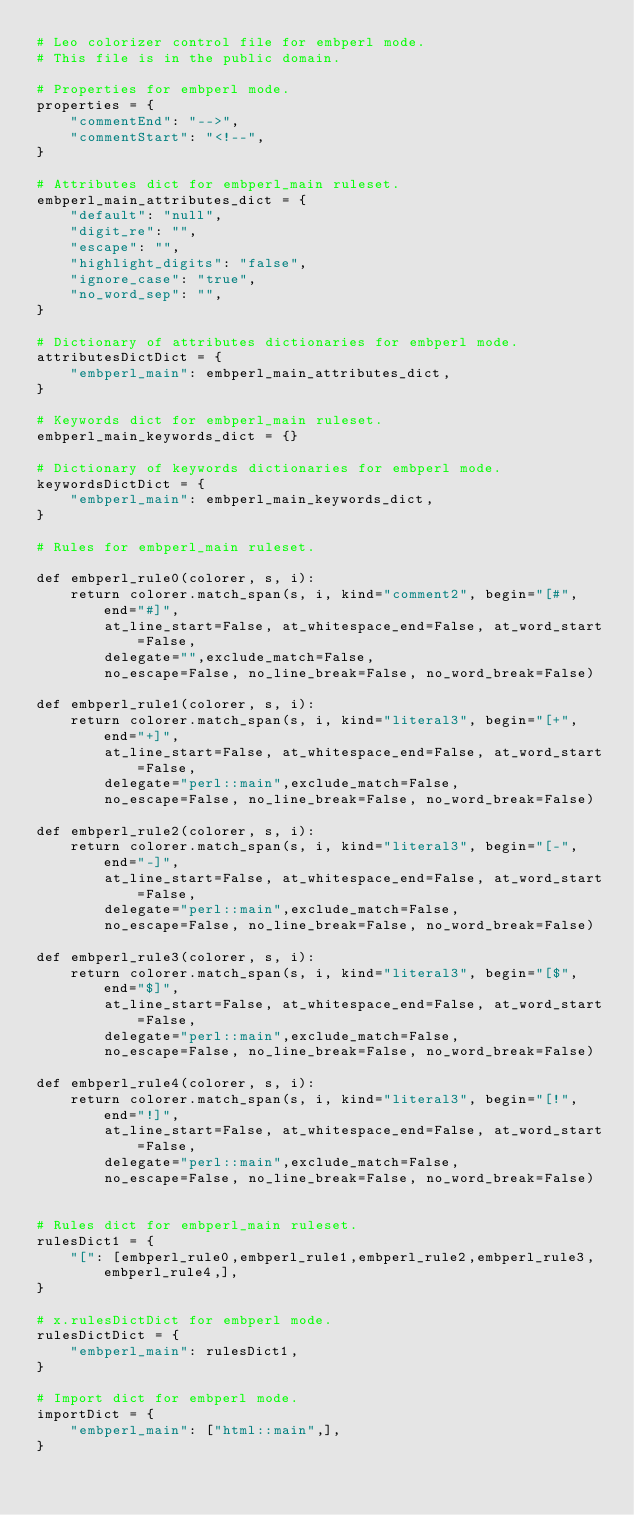<code> <loc_0><loc_0><loc_500><loc_500><_Python_># Leo colorizer control file for embperl mode.
# This file is in the public domain.

# Properties for embperl mode.
properties = {
    "commentEnd": "-->",
    "commentStart": "<!--",
}

# Attributes dict for embperl_main ruleset.
embperl_main_attributes_dict = {
    "default": "null",
    "digit_re": "",
    "escape": "",
    "highlight_digits": "false",
    "ignore_case": "true",
    "no_word_sep": "",
}

# Dictionary of attributes dictionaries for embperl mode.
attributesDictDict = {
    "embperl_main": embperl_main_attributes_dict,
}

# Keywords dict for embperl_main ruleset.
embperl_main_keywords_dict = {}

# Dictionary of keywords dictionaries for embperl mode.
keywordsDictDict = {
    "embperl_main": embperl_main_keywords_dict,
}

# Rules for embperl_main ruleset.

def embperl_rule0(colorer, s, i):
    return colorer.match_span(s, i, kind="comment2", begin="[#", end="#]",
        at_line_start=False, at_whitespace_end=False, at_word_start=False,
        delegate="",exclude_match=False,
        no_escape=False, no_line_break=False, no_word_break=False)

def embperl_rule1(colorer, s, i):
    return colorer.match_span(s, i, kind="literal3", begin="[+", end="+]",
        at_line_start=False, at_whitespace_end=False, at_word_start=False,
        delegate="perl::main",exclude_match=False,
        no_escape=False, no_line_break=False, no_word_break=False)

def embperl_rule2(colorer, s, i):
    return colorer.match_span(s, i, kind="literal3", begin="[-", end="-]",
        at_line_start=False, at_whitespace_end=False, at_word_start=False,
        delegate="perl::main",exclude_match=False,
        no_escape=False, no_line_break=False, no_word_break=False)

def embperl_rule3(colorer, s, i):
    return colorer.match_span(s, i, kind="literal3", begin="[$", end="$]",
        at_line_start=False, at_whitespace_end=False, at_word_start=False,
        delegate="perl::main",exclude_match=False,
        no_escape=False, no_line_break=False, no_word_break=False)

def embperl_rule4(colorer, s, i):
    return colorer.match_span(s, i, kind="literal3", begin="[!", end="!]",
        at_line_start=False, at_whitespace_end=False, at_word_start=False,
        delegate="perl::main",exclude_match=False,
        no_escape=False, no_line_break=False, no_word_break=False)


# Rules dict for embperl_main ruleset.
rulesDict1 = {
    "[": [embperl_rule0,embperl_rule1,embperl_rule2,embperl_rule3,embperl_rule4,],
}

# x.rulesDictDict for embperl mode.
rulesDictDict = {
    "embperl_main": rulesDict1,
}

# Import dict for embperl mode.
importDict = {
    "embperl_main": ["html::main",],
}

</code> 